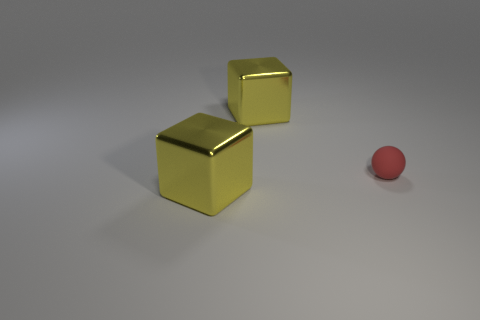There is a yellow thing that is in front of the red matte object; is it the same shape as the large yellow metal thing behind the small matte sphere?
Provide a succinct answer. Yes. How many things are tiny spheres or metal objects left of the rubber object?
Your answer should be very brief. 3. Are there any other things that are the same shape as the red rubber thing?
Offer a very short reply. No. What number of things are either gray shiny cylinders or red spheres?
Provide a short and direct response. 1. There is a red thing; does it have the same size as the shiny object behind the sphere?
Give a very brief answer. No. What color is the tiny thing to the right of the big yellow shiny thing to the right of the big yellow cube in front of the rubber object?
Make the answer very short. Red. The tiny thing has what color?
Your answer should be very brief. Red. Is the size of the yellow shiny thing behind the matte thing the same as the yellow cube that is in front of the rubber thing?
Offer a very short reply. Yes. Is there a big shiny block that is behind the shiny block that is in front of the yellow thing that is behind the tiny red sphere?
Your answer should be compact. Yes. There is a object that is right of the large yellow metal block to the right of the big object in front of the tiny sphere; how big is it?
Give a very brief answer. Small. 